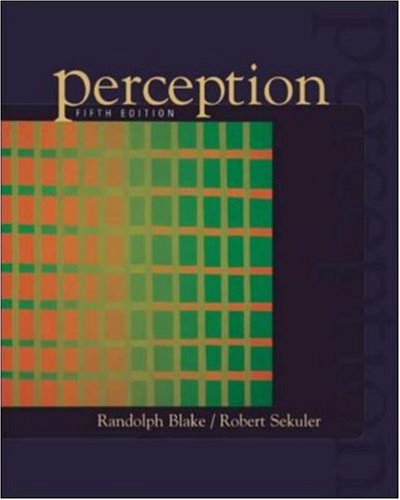What specific concepts are discussed in this book related to visual perception? This book delves into various facets of visual perception including depth perception, motion detection, color vision, and perceptual illusions. 